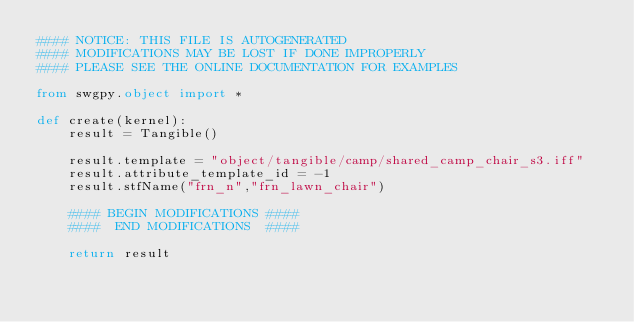Convert code to text. <code><loc_0><loc_0><loc_500><loc_500><_Python_>#### NOTICE: THIS FILE IS AUTOGENERATED
#### MODIFICATIONS MAY BE LOST IF DONE IMPROPERLY
#### PLEASE SEE THE ONLINE DOCUMENTATION FOR EXAMPLES

from swgpy.object import *	

def create(kernel):
	result = Tangible()

	result.template = "object/tangible/camp/shared_camp_chair_s3.iff"
	result.attribute_template_id = -1
	result.stfName("frn_n","frn_lawn_chair")		
	
	#### BEGIN MODIFICATIONS ####
	####  END MODIFICATIONS  ####
	
	return result</code> 